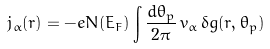Convert formula to latex. <formula><loc_0><loc_0><loc_500><loc_500>j _ { \alpha } ( { r } ) = - e N ( E _ { F } ) \int \frac { d \theta _ { p } } { 2 \pi } \, v _ { \alpha } \, \delta g ( { r } , \theta _ { p } )</formula> 